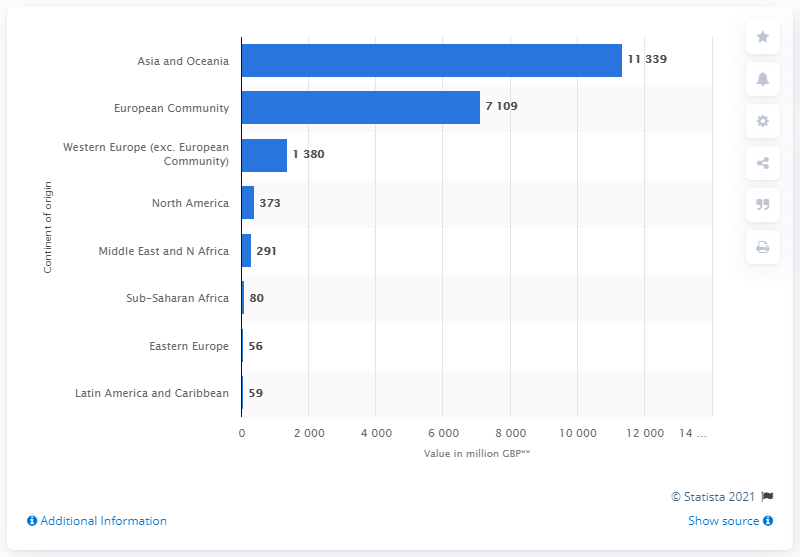Point out several critical features in this image. In 2019, the UK imported 373 pounds worth of clothing from North America. 